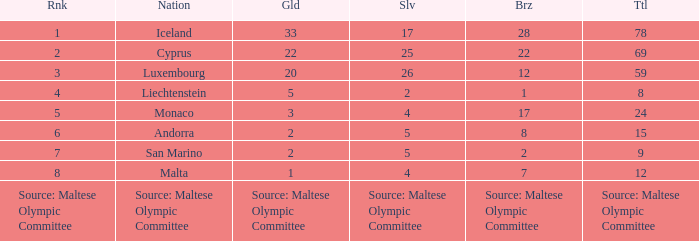What is the standing of the nation possessing a bronze medal according to the maltese olympic committee? Source: Maltese Olympic Committee. 